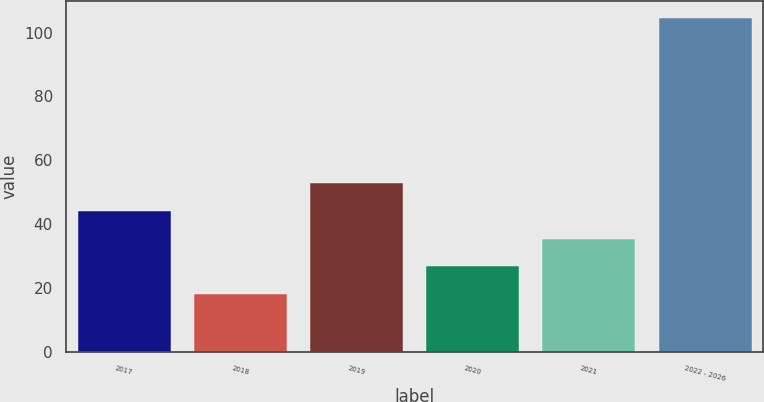<chart> <loc_0><loc_0><loc_500><loc_500><bar_chart><fcel>2017<fcel>2018<fcel>2019<fcel>2020<fcel>2021<fcel>2022 - 2026<nl><fcel>44.22<fcel>18.3<fcel>52.86<fcel>26.94<fcel>35.58<fcel>104.7<nl></chart> 